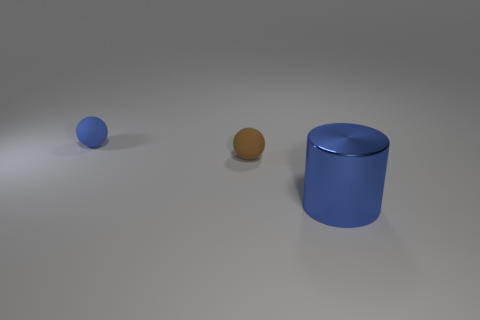Add 2 gray cylinders. How many objects exist? 5 Subtract all balls. How many objects are left? 1 Add 3 brown balls. How many brown balls are left? 4 Add 3 green things. How many green things exist? 3 Subtract 0 brown blocks. How many objects are left? 3 Subtract all tiny blue rubber balls. Subtract all cylinders. How many objects are left? 1 